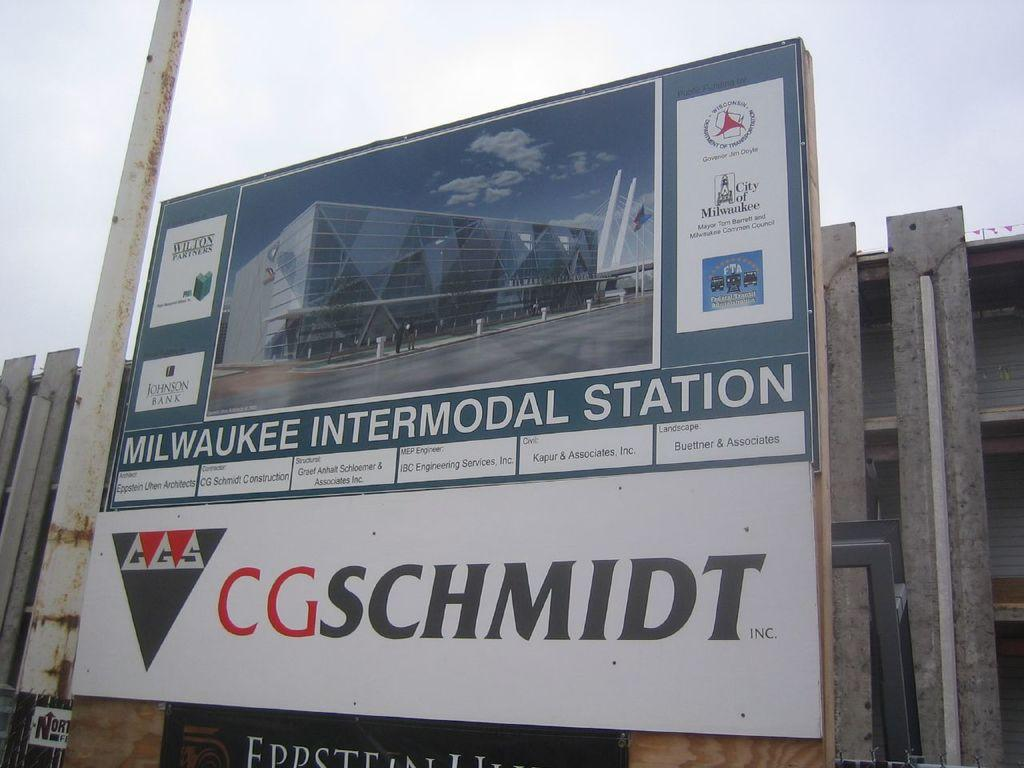<image>
Describe the image concisely. A billboard by CGSchmidt advertising the Milwaukee Intermodal Station 